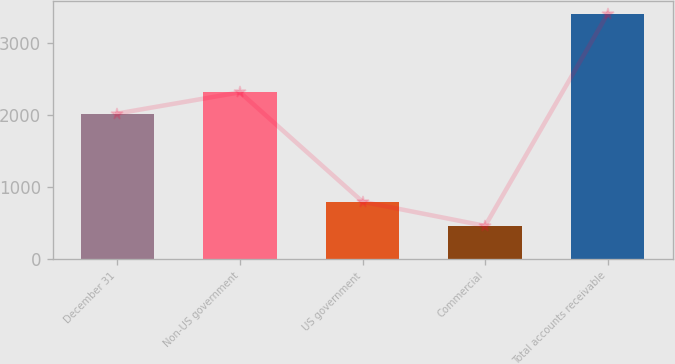Convert chart to OTSL. <chart><loc_0><loc_0><loc_500><loc_500><bar_chart><fcel>December 31<fcel>Non-US government<fcel>US government<fcel>Commercial<fcel>Total accounts receivable<nl><fcel>2016<fcel>2310<fcel>793<fcel>459<fcel>3399<nl></chart> 